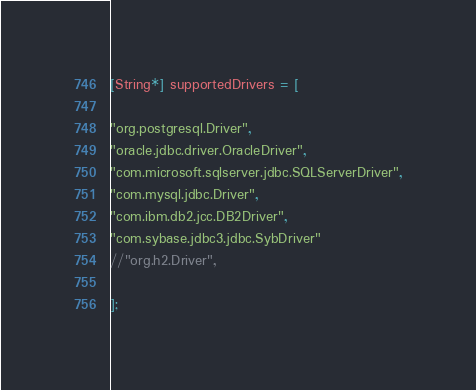<code> <loc_0><loc_0><loc_500><loc_500><_Ceylon_>[String*] supportedDrivers = [

"org.postgresql.Driver",
"oracle.jdbc.driver.OracleDriver",
"com.microsoft.sqlserver.jdbc.SQLServerDriver",
"com.mysql.jdbc.Driver",
"com.ibm.db2.jcc.DB2Driver",
"com.sybase.jdbc3.jdbc.SybDriver"
//"org.h2.Driver",

];</code> 